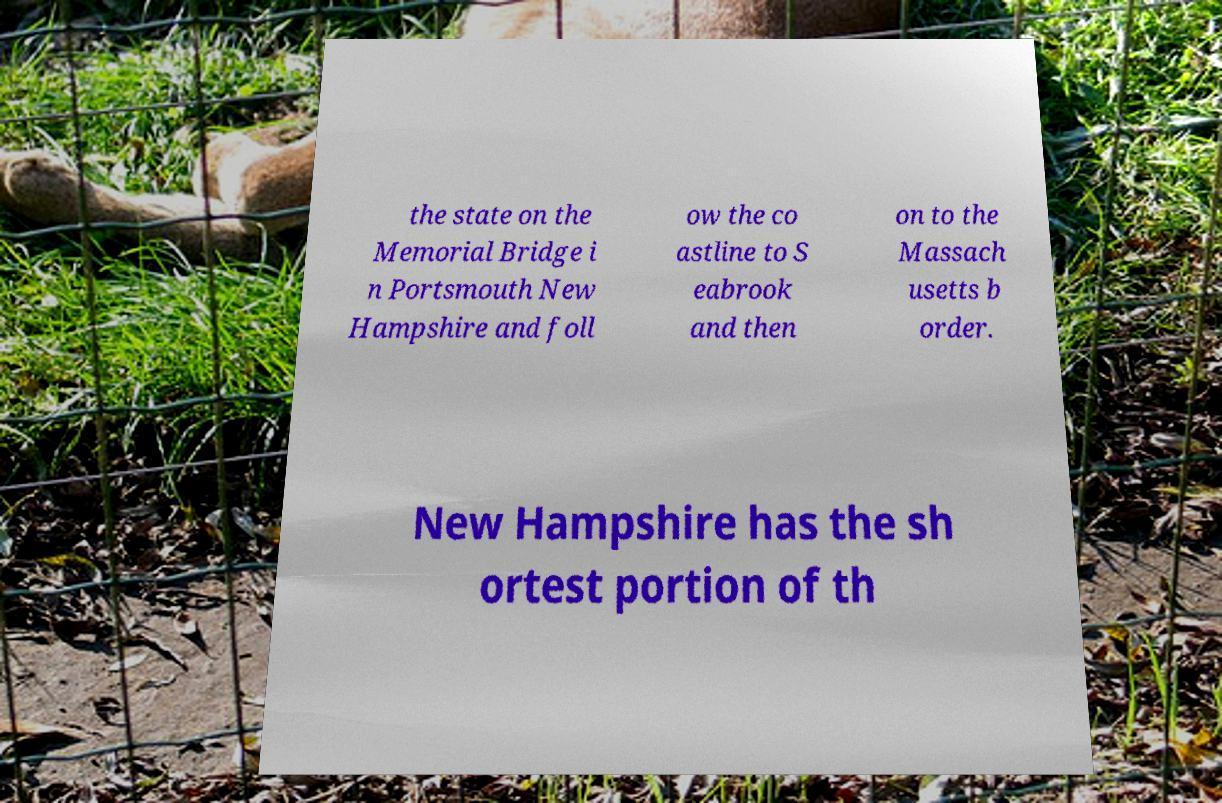Please read and relay the text visible in this image. What does it say? the state on the Memorial Bridge i n Portsmouth New Hampshire and foll ow the co astline to S eabrook and then on to the Massach usetts b order. New Hampshire has the sh ortest portion of th 